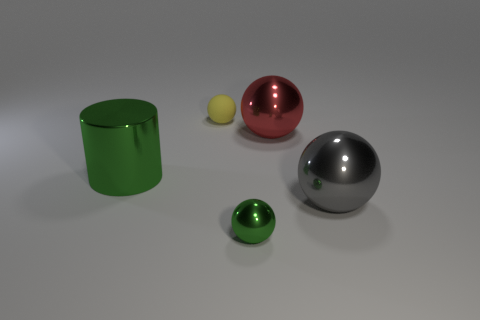Add 4 tiny green metal balls. How many objects exist? 9 Subtract all spheres. How many objects are left? 1 Subtract 1 yellow balls. How many objects are left? 4 Subtract all rubber objects. Subtract all red balls. How many objects are left? 3 Add 4 yellow spheres. How many yellow spheres are left? 5 Add 2 green spheres. How many green spheres exist? 3 